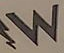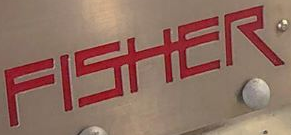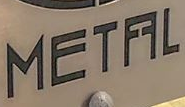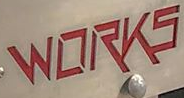Transcribe the words shown in these images in order, separated by a semicolon. W; FISHER; METFFL; WORKS 